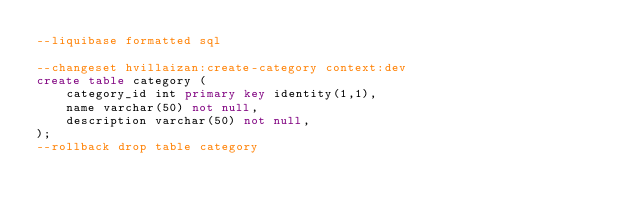Convert code to text. <code><loc_0><loc_0><loc_500><loc_500><_SQL_>--liquibase formatted sql

--changeset hvillaizan:create-category context:dev
create table category (
    category_id int primary key identity(1,1),
    name varchar(50) not null,
    description varchar(50) not null,
);
--rollback drop table category</code> 